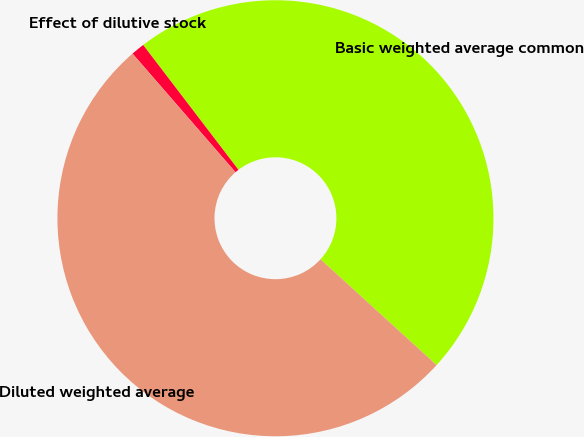Convert chart. <chart><loc_0><loc_0><loc_500><loc_500><pie_chart><fcel>Basic weighted average common<fcel>Effect of dilutive stock<fcel>Diluted weighted average<nl><fcel>47.14%<fcel>1.0%<fcel>51.86%<nl></chart> 